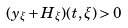<formula> <loc_0><loc_0><loc_500><loc_500>( y _ { \xi } + H _ { \xi } ) ( t , \xi ) > 0</formula> 